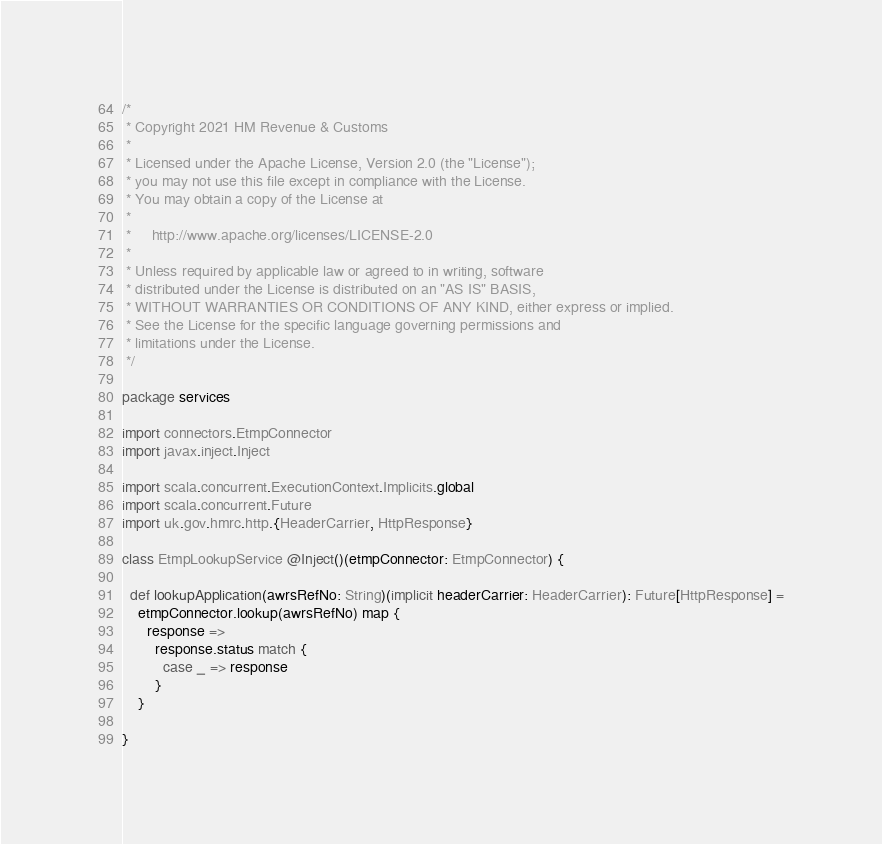Convert code to text. <code><loc_0><loc_0><loc_500><loc_500><_Scala_>/*
 * Copyright 2021 HM Revenue & Customs
 *
 * Licensed under the Apache License, Version 2.0 (the "License");
 * you may not use this file except in compliance with the License.
 * You may obtain a copy of the License at
 *
 *     http://www.apache.org/licenses/LICENSE-2.0
 *
 * Unless required by applicable law or agreed to in writing, software
 * distributed under the License is distributed on an "AS IS" BASIS,
 * WITHOUT WARRANTIES OR CONDITIONS OF ANY KIND, either express or implied.
 * See the License for the specific language governing permissions and
 * limitations under the License.
 */

package services

import connectors.EtmpConnector
import javax.inject.Inject

import scala.concurrent.ExecutionContext.Implicits.global
import scala.concurrent.Future
import uk.gov.hmrc.http.{HeaderCarrier, HttpResponse}

class EtmpLookupService @Inject()(etmpConnector: EtmpConnector) {

  def lookupApplication(awrsRefNo: String)(implicit headerCarrier: HeaderCarrier): Future[HttpResponse] =
    etmpConnector.lookup(awrsRefNo) map {
      response =>
        response.status match {
          case _ => response
        }
    }

}
</code> 